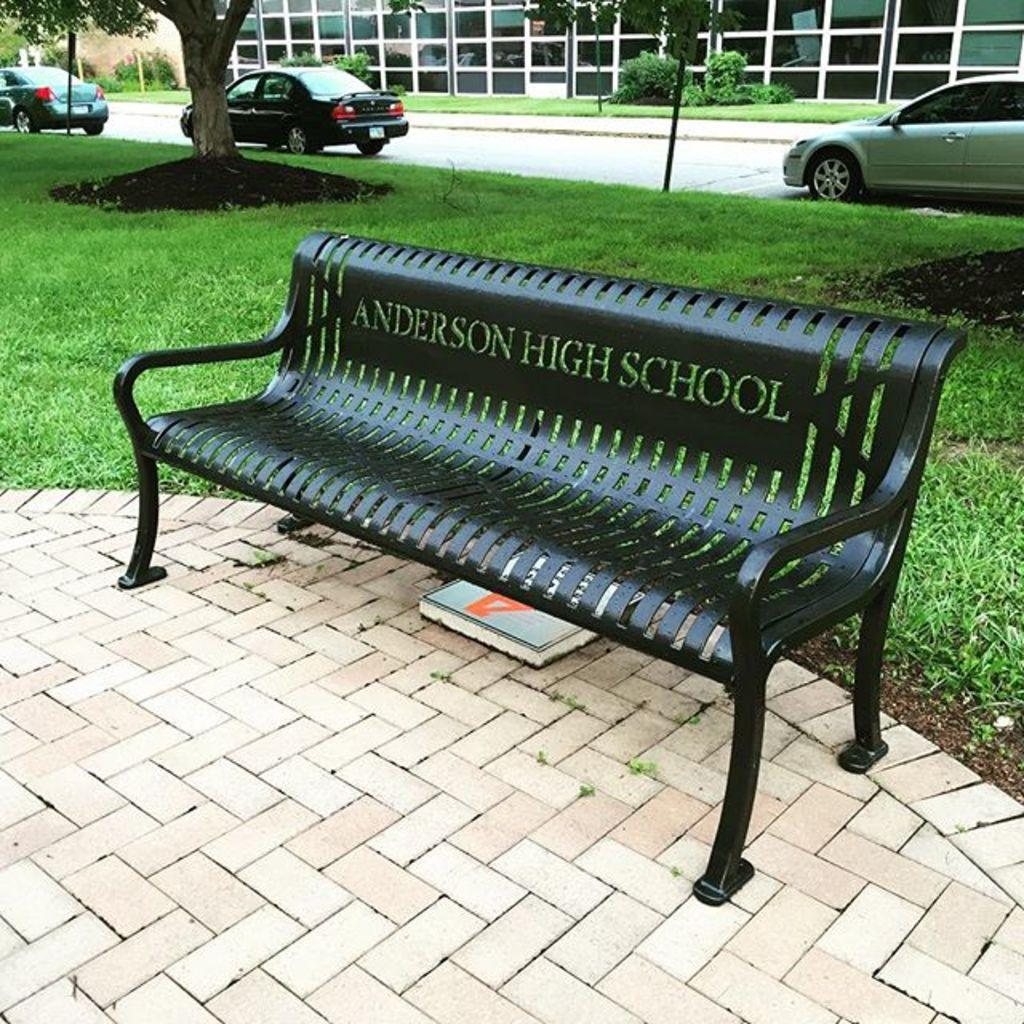What is located in the center of the image? There is a bench in the center of the image. What type of vegetation is present in the image? There is grass in the image. What can be seen in the background of the image? There are trees, cars, and a building in the background of the image. What type of pets are attempting to jump over the bench in the image? There are no pets present in the image, and no one is attempting to jump over the bench. 